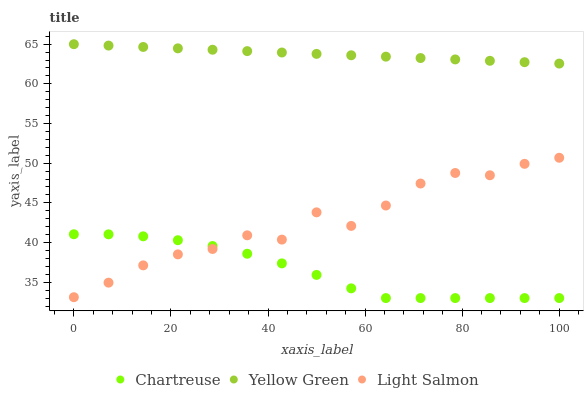Does Chartreuse have the minimum area under the curve?
Answer yes or no. Yes. Does Yellow Green have the maximum area under the curve?
Answer yes or no. Yes. Does Light Salmon have the minimum area under the curve?
Answer yes or no. No. Does Light Salmon have the maximum area under the curve?
Answer yes or no. No. Is Yellow Green the smoothest?
Answer yes or no. Yes. Is Light Salmon the roughest?
Answer yes or no. Yes. Is Light Salmon the smoothest?
Answer yes or no. No. Is Yellow Green the roughest?
Answer yes or no. No. Does Chartreuse have the lowest value?
Answer yes or no. Yes. Does Light Salmon have the lowest value?
Answer yes or no. No. Does Yellow Green have the highest value?
Answer yes or no. Yes. Does Light Salmon have the highest value?
Answer yes or no. No. Is Chartreuse less than Yellow Green?
Answer yes or no. Yes. Is Yellow Green greater than Light Salmon?
Answer yes or no. Yes. Does Chartreuse intersect Light Salmon?
Answer yes or no. Yes. Is Chartreuse less than Light Salmon?
Answer yes or no. No. Is Chartreuse greater than Light Salmon?
Answer yes or no. No. Does Chartreuse intersect Yellow Green?
Answer yes or no. No. 